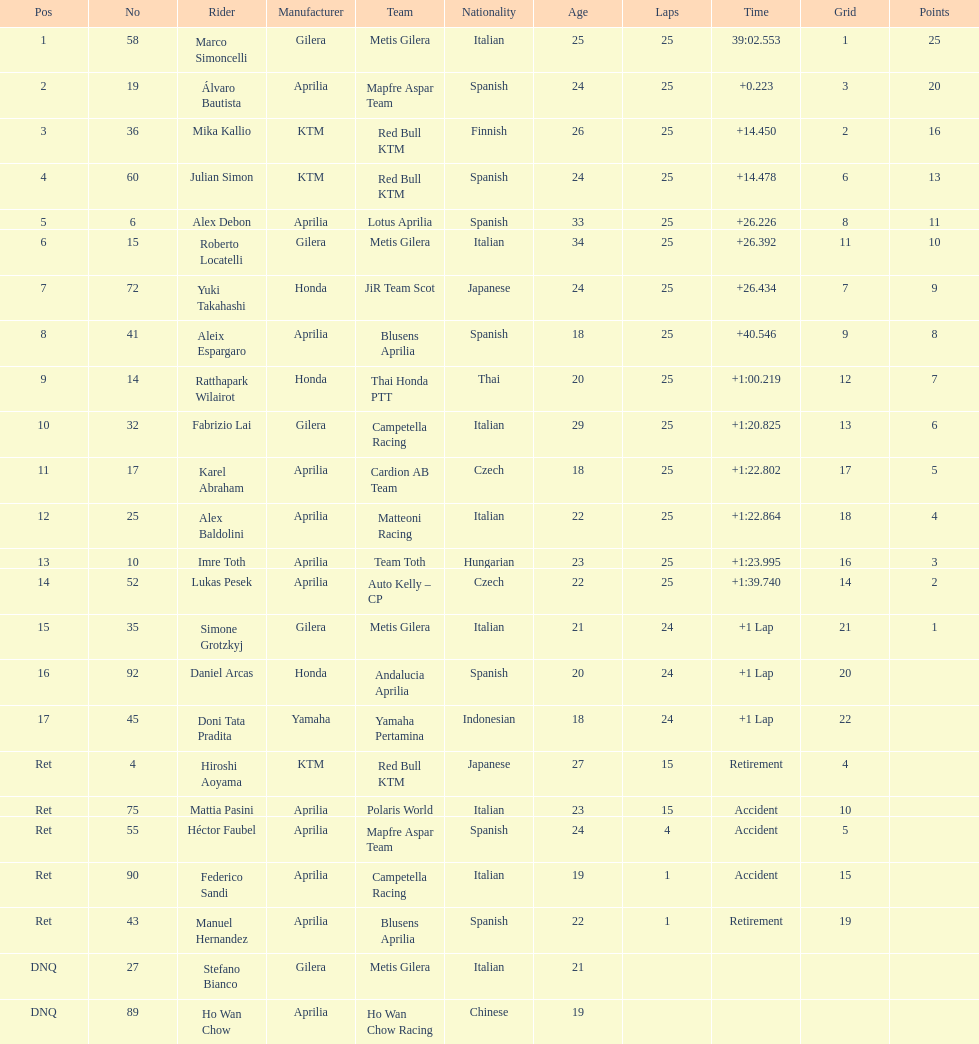How many riders manufacturer is honda? 3. 